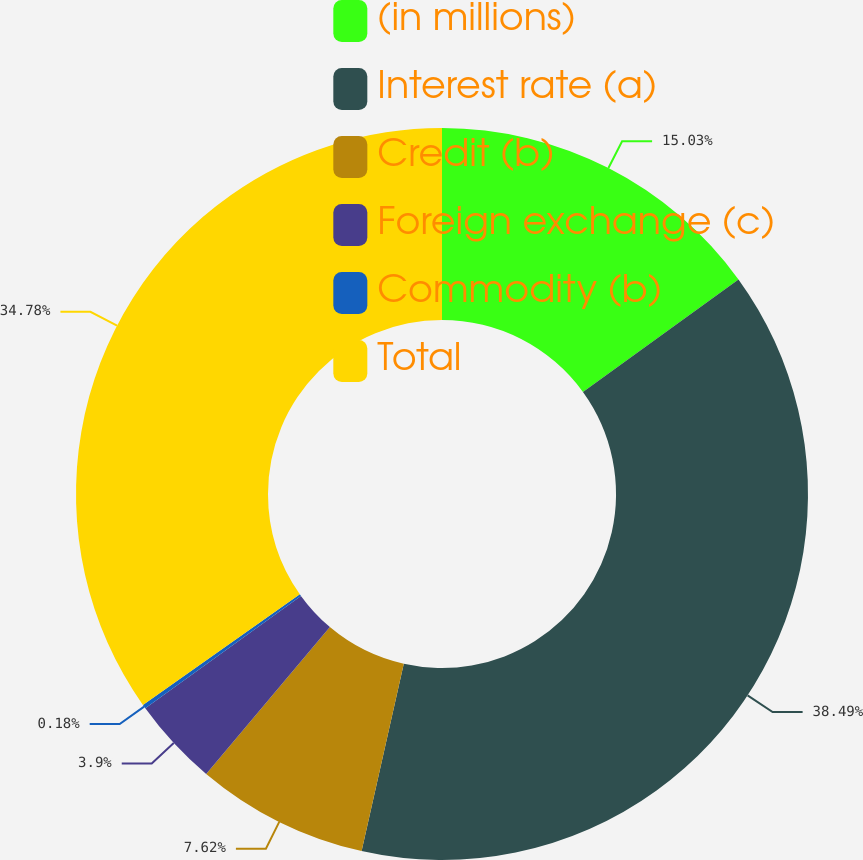Convert chart to OTSL. <chart><loc_0><loc_0><loc_500><loc_500><pie_chart><fcel>(in millions)<fcel>Interest rate (a)<fcel>Credit (b)<fcel>Foreign exchange (c)<fcel>Commodity (b)<fcel>Total<nl><fcel>15.03%<fcel>38.5%<fcel>7.62%<fcel>3.9%<fcel>0.18%<fcel>34.78%<nl></chart> 